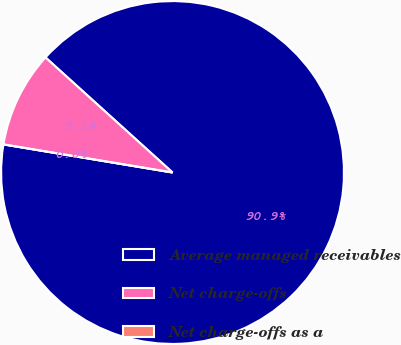Convert chart. <chart><loc_0><loc_0><loc_500><loc_500><pie_chart><fcel>Average managed receivables<fcel>Net charge-offs<fcel>Net charge-offs as a<nl><fcel>90.91%<fcel>9.09%<fcel>0.0%<nl></chart> 